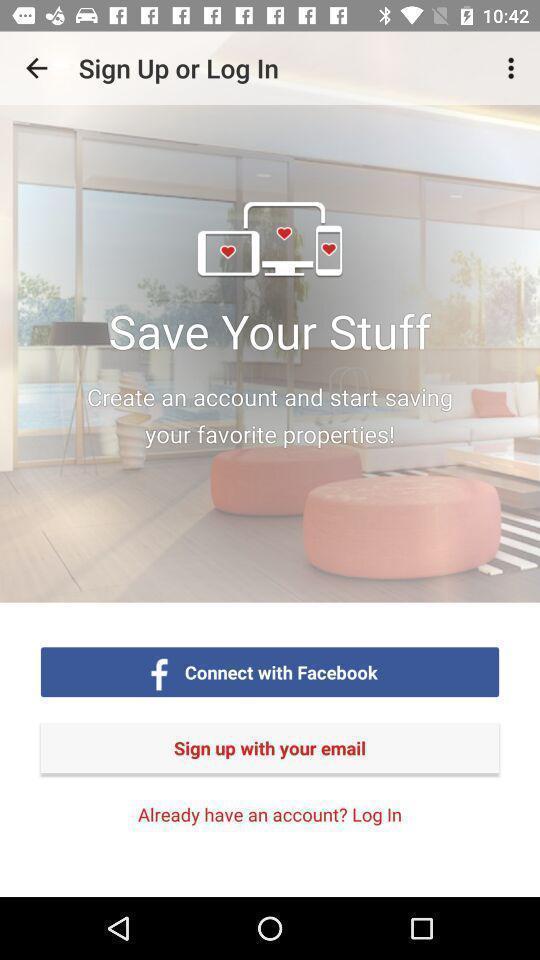What details can you identify in this image? Sign up page for the property search app. 